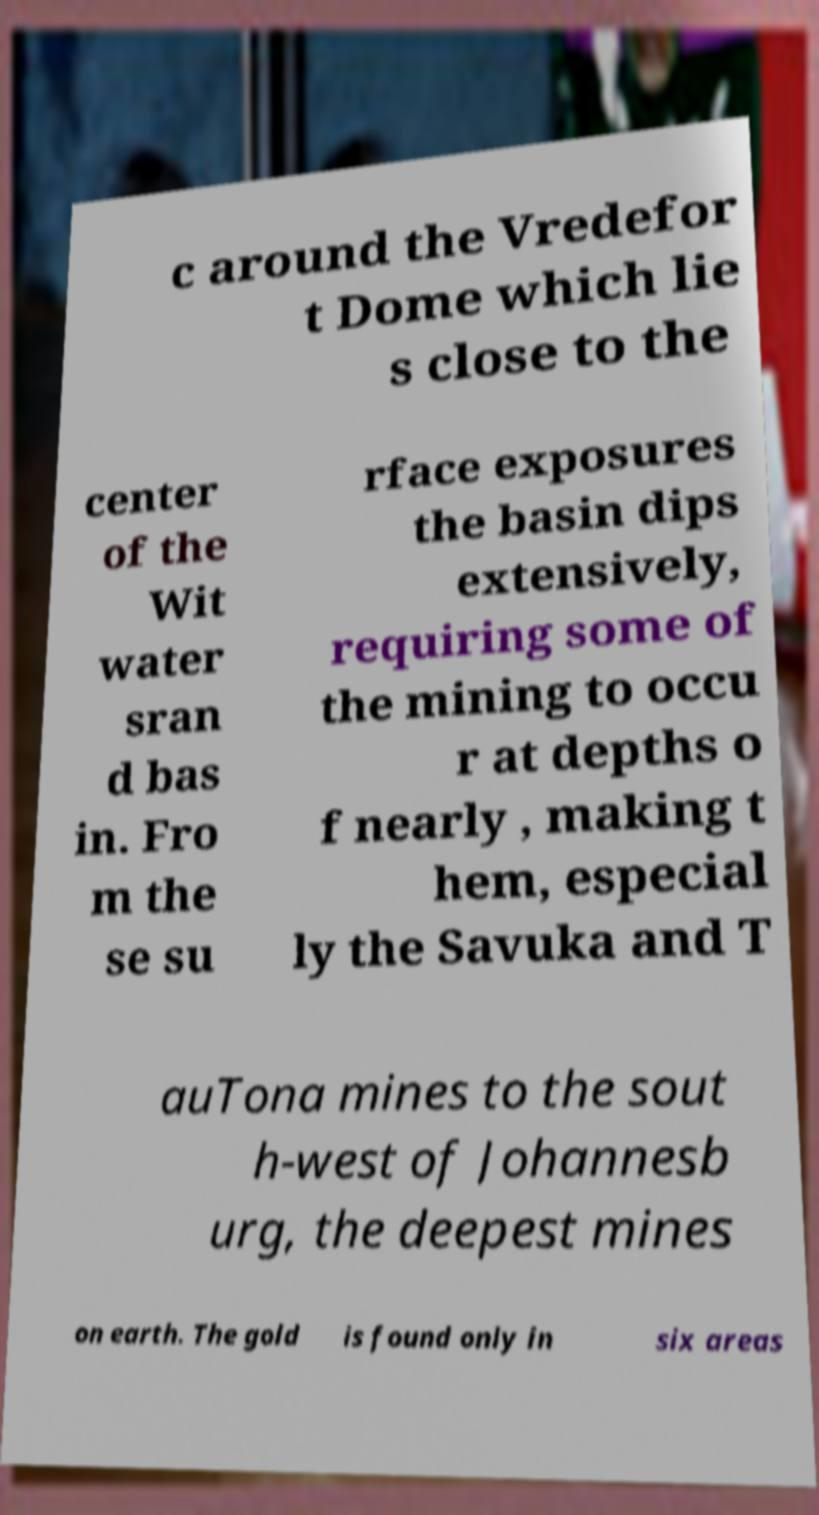Please read and relay the text visible in this image. What does it say? c around the Vredefor t Dome which lie s close to the center of the Wit water sran d bas in. Fro m the se su rface exposures the basin dips extensively, requiring some of the mining to occu r at depths o f nearly , making t hem, especial ly the Savuka and T auTona mines to the sout h-west of Johannesb urg, the deepest mines on earth. The gold is found only in six areas 